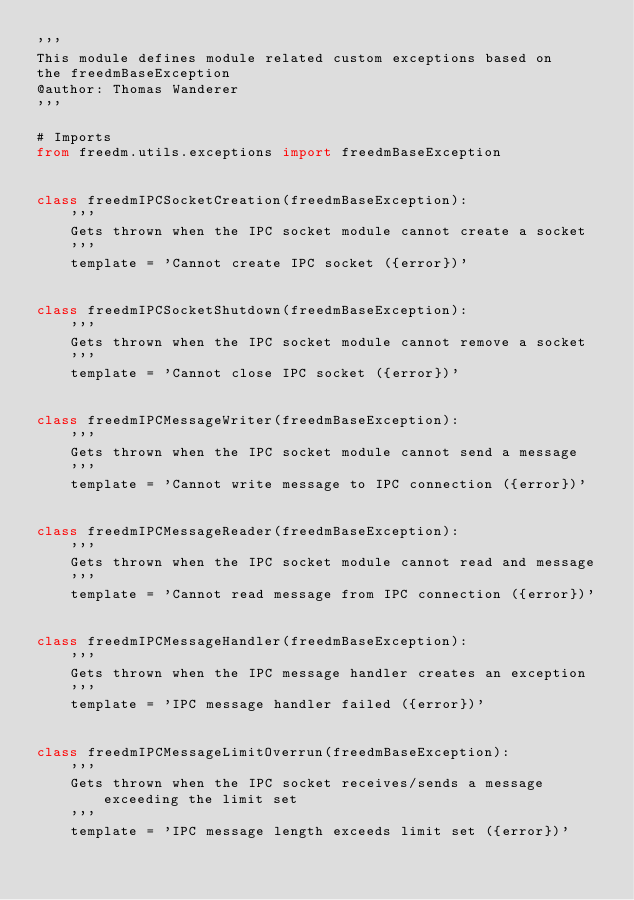<code> <loc_0><loc_0><loc_500><loc_500><_Python_>'''
This module defines module related custom exceptions based on
the freedmBaseException
@author: Thomas Wanderer
'''

# Imports
from freedm.utils.exceptions import freedmBaseException


class freedmIPCSocketCreation(freedmBaseException):
    '''
    Gets thrown when the IPC socket module cannot create a socket
    '''
    template = 'Cannot create IPC socket ({error})'
    
    
class freedmIPCSocketShutdown(freedmBaseException):
    '''
    Gets thrown when the IPC socket module cannot remove a socket
    '''
    template = 'Cannot close IPC socket ({error})'
    

class freedmIPCMessageWriter(freedmBaseException):
    '''
    Gets thrown when the IPC socket module cannot send a message
    '''
    template = 'Cannot write message to IPC connection ({error})'
    

class freedmIPCMessageReader(freedmBaseException):
    '''
    Gets thrown when the IPC socket module cannot read and message
    '''
    template = 'Cannot read message from IPC connection ({error})'
    
    
class freedmIPCMessageHandler(freedmBaseException):
    '''
    Gets thrown when the IPC message handler creates an exception
    '''
    template = 'IPC message handler failed ({error})'
    
    
class freedmIPCMessageLimitOverrun(freedmBaseException):
    '''
    Gets thrown when the IPC socket receives/sends a message exceeding the limit set
    '''
    template = 'IPC message length exceeds limit set ({error})'</code> 